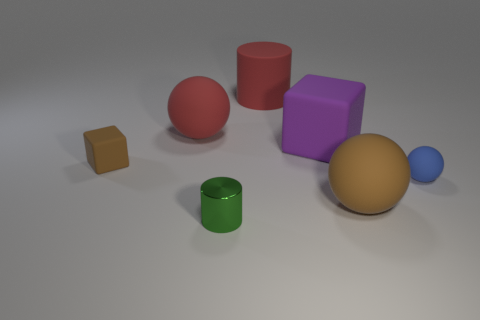There is a brown matte object behind the big matte sphere right of the large red rubber sphere; what size is it?
Provide a succinct answer. Small. What size is the rubber ball that is the same color as the big matte cylinder?
Make the answer very short. Large. What number of other things are the same size as the purple object?
Make the answer very short. 3. What is the color of the large thing in front of the brown object that is behind the large thing in front of the big rubber cube?
Ensure brevity in your answer.  Brown. How many other things are the same shape as the large purple matte thing?
Your answer should be compact. 1. There is a brown thing to the left of the large brown rubber sphere; what shape is it?
Your answer should be very brief. Cube. There is a big sphere on the right side of the tiny green metal cylinder; is there a red rubber thing in front of it?
Give a very brief answer. No. What is the color of the large object that is both left of the large rubber cube and in front of the big cylinder?
Give a very brief answer. Red. There is a big ball behind the brown object right of the metallic cylinder; is there a brown cube to the right of it?
Your answer should be very brief. No. There is a brown matte object that is the same shape as the big purple object; what is its size?
Keep it short and to the point. Small. 